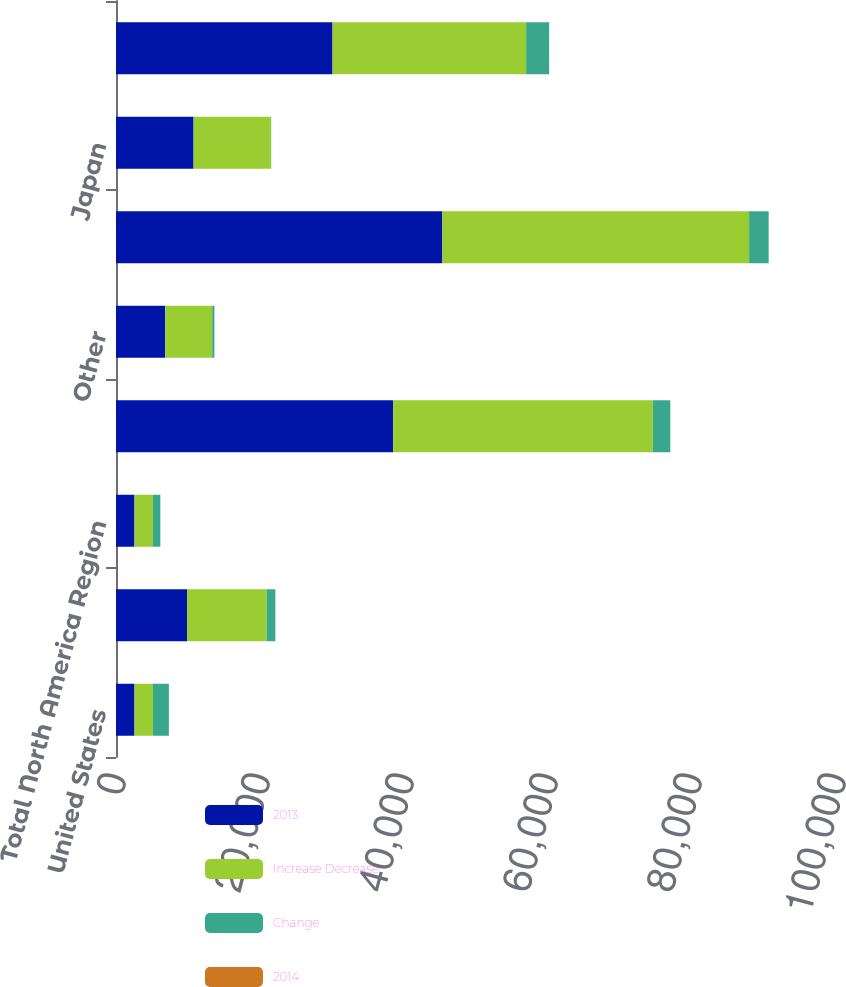Convert chart. <chart><loc_0><loc_0><loc_500><loc_500><stacked_bar_chart><ecel><fcel>United States<fcel>Canada<fcel>Total North America Region<fcel>Europe (b)<fcel>Other<fcel>Total EMEA Region<fcel>Japan<fcel>Total Asia Pacific Region<nl><fcel>2013<fcel>2564.5<fcel>9871<fcel>2564.5<fcel>38491<fcel>6832<fcel>45323<fcel>10775<fcel>30074<nl><fcel>Increase Decrease<fcel>2564.5<fcel>11062<fcel>2564.5<fcel>36076<fcel>6533<fcel>42609<fcel>10751<fcel>26890<nl><fcel>Change<fcel>2216<fcel>1191<fcel>1025<fcel>2415<fcel>299<fcel>2714<fcel>24<fcel>3184<nl><fcel>2014<fcel>1.3<fcel>10.8<fcel>0.6<fcel>6.7<fcel>4.6<fcel>6.4<fcel>0.2<fcel>11.8<nl></chart> 